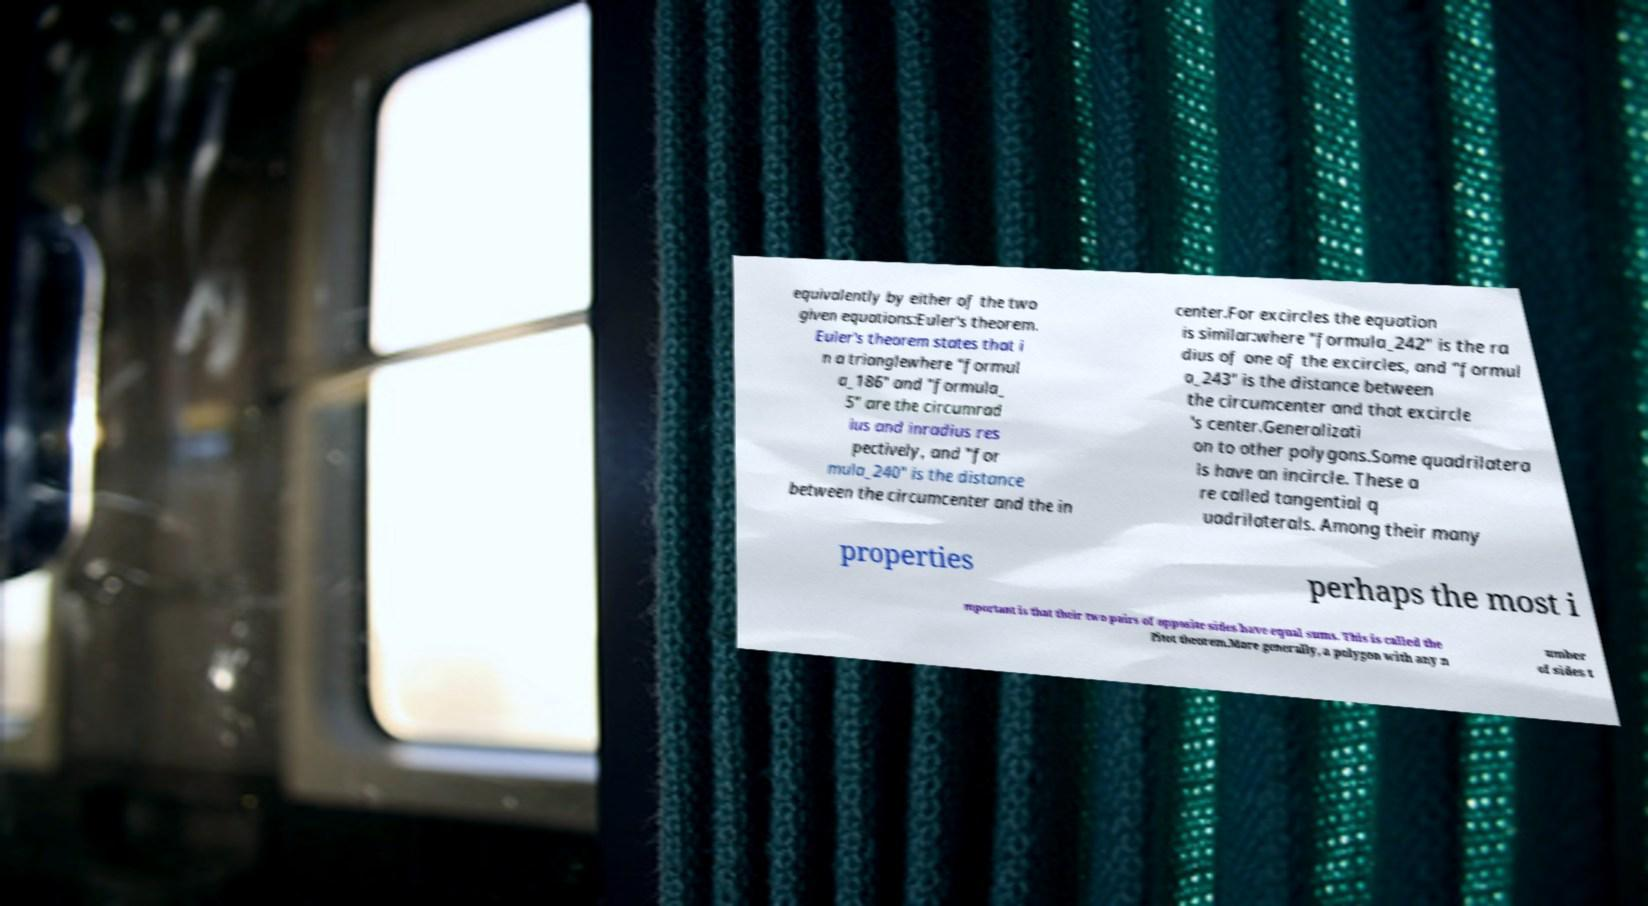Could you assist in decoding the text presented in this image and type it out clearly? equivalently by either of the two given equations:Euler's theorem. Euler's theorem states that i n a trianglewhere "formul a_186" and "formula_ 5" are the circumrad ius and inradius res pectively, and "for mula_240" is the distance between the circumcenter and the in center.For excircles the equation is similar:where "formula_242" is the ra dius of one of the excircles, and "formul a_243" is the distance between the circumcenter and that excircle 's center.Generalizati on to other polygons.Some quadrilatera ls have an incircle. These a re called tangential q uadrilaterals. Among their many properties perhaps the most i mportant is that their two pairs of opposite sides have equal sums. This is called the Pitot theorem.More generally, a polygon with any n umber of sides t 